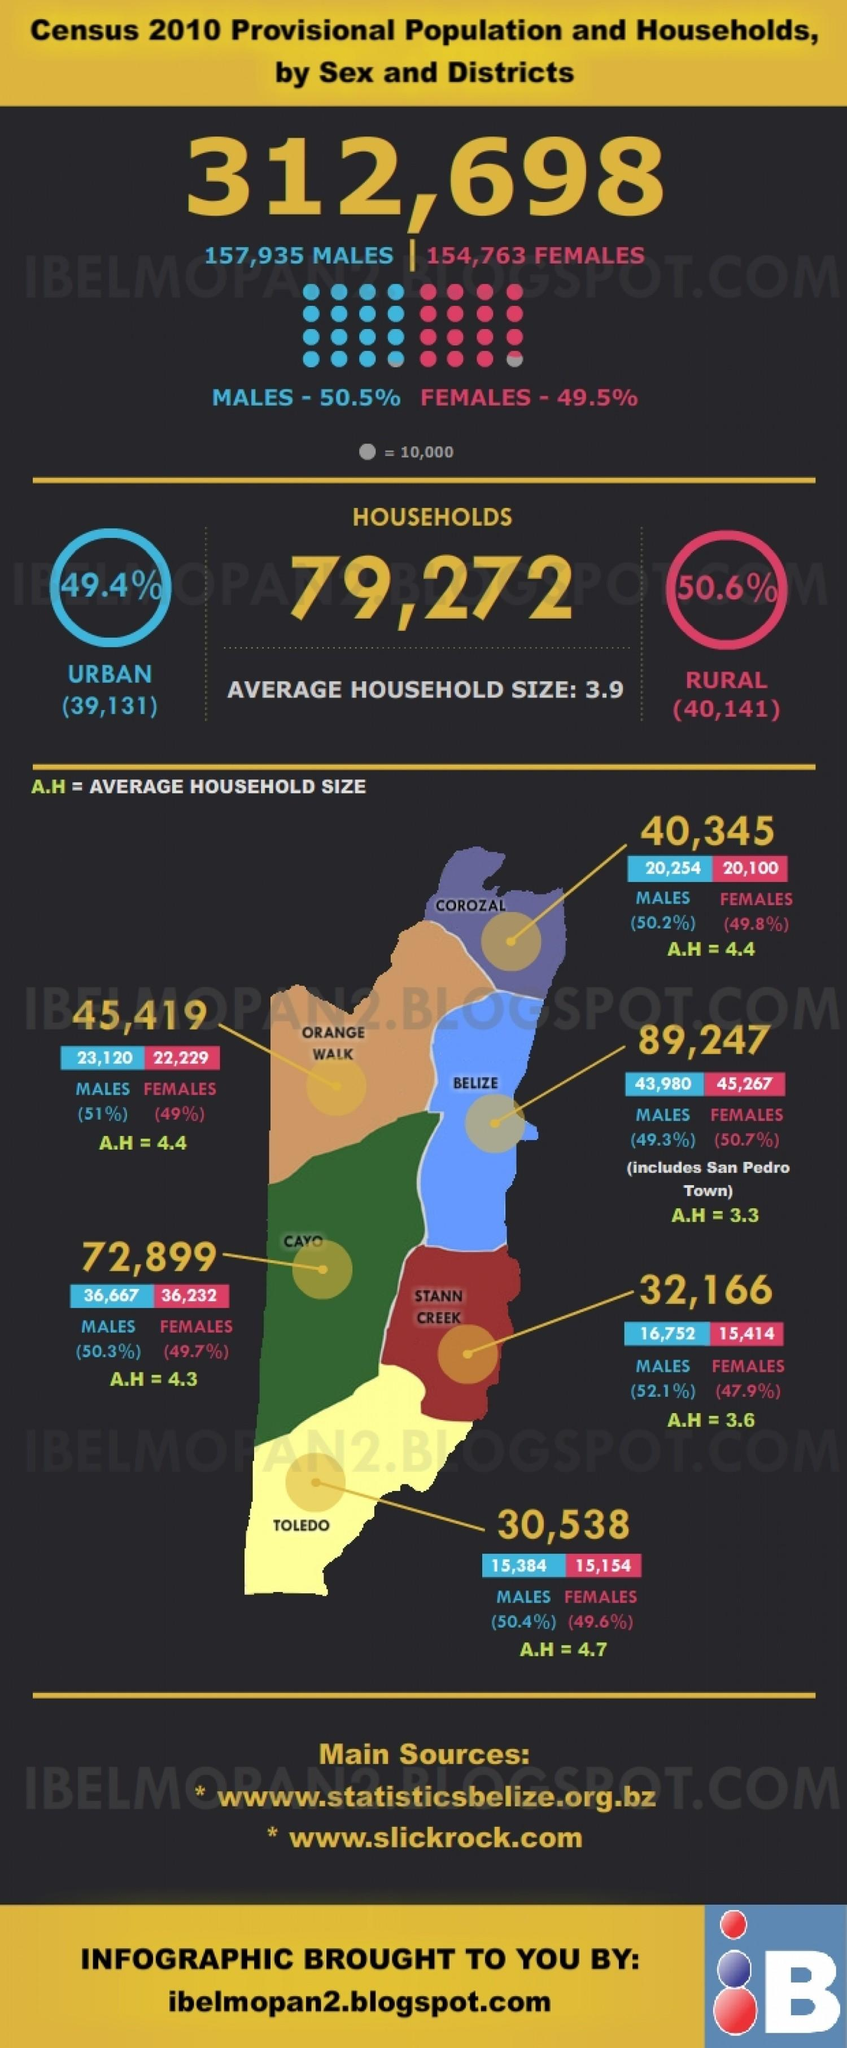Mention a couple of crucial points in this snapshot. The male population is highest in Belize, in the district. In how many districts does the average household size fall below 4 individuals? Of the districts, how many have an average household size of 4.4? In how many districts does the average household size exceed 4? 